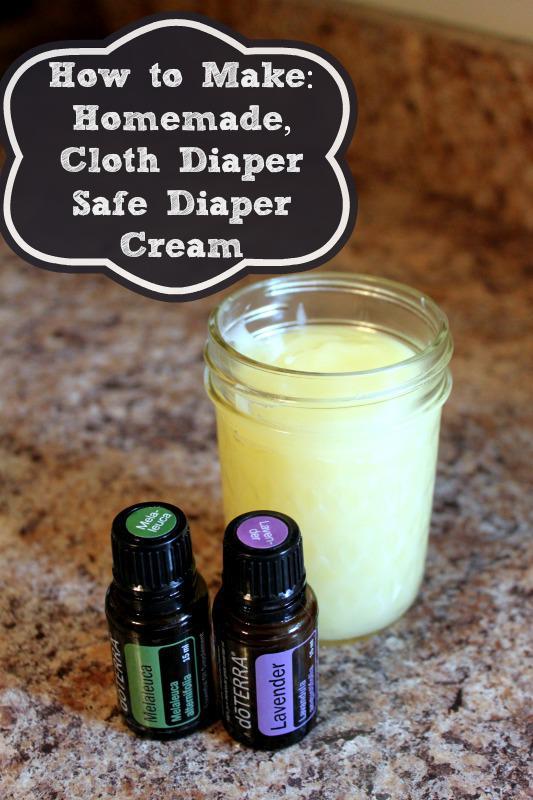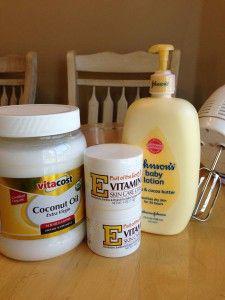The first image is the image on the left, the second image is the image on the right. Analyze the images presented: Is the assertion "A pump bottle of lotion is in one image with two other labeled products, while the second image shows an open jar of body cream among other items." valid? Answer yes or no. Yes. The first image is the image on the left, the second image is the image on the right. For the images displayed, is the sentence "An image includes an unlidded glass jar containing a pale creamy substance." factually correct? Answer yes or no. Yes. 